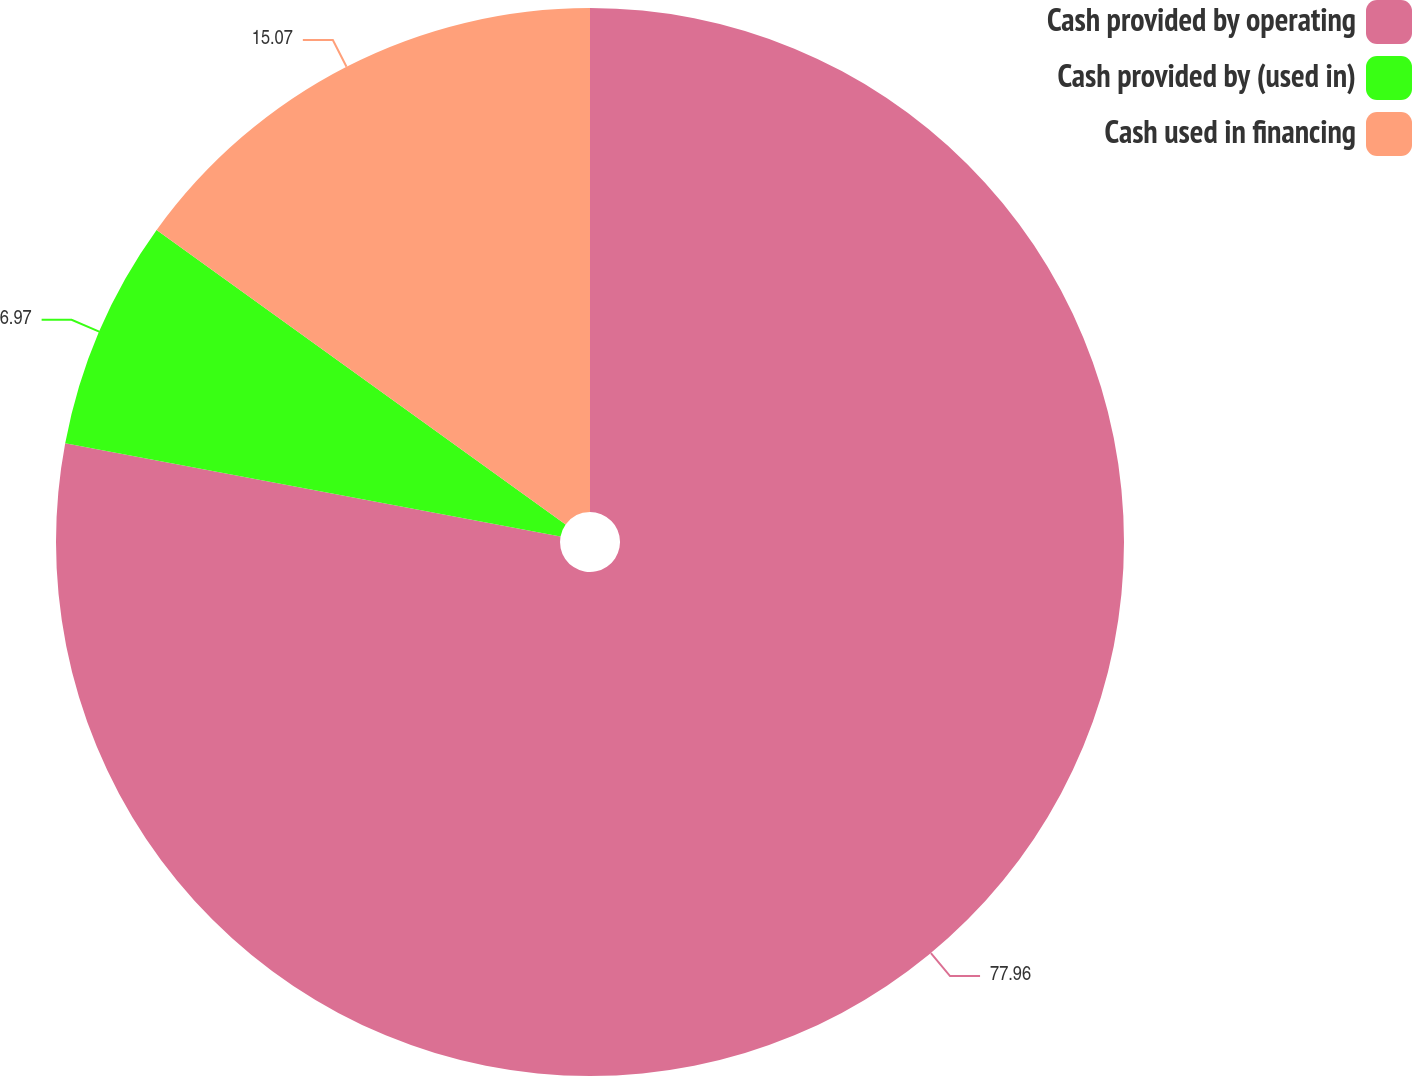Convert chart to OTSL. <chart><loc_0><loc_0><loc_500><loc_500><pie_chart><fcel>Cash provided by operating<fcel>Cash provided by (used in)<fcel>Cash used in financing<nl><fcel>77.96%<fcel>6.97%<fcel>15.07%<nl></chart> 